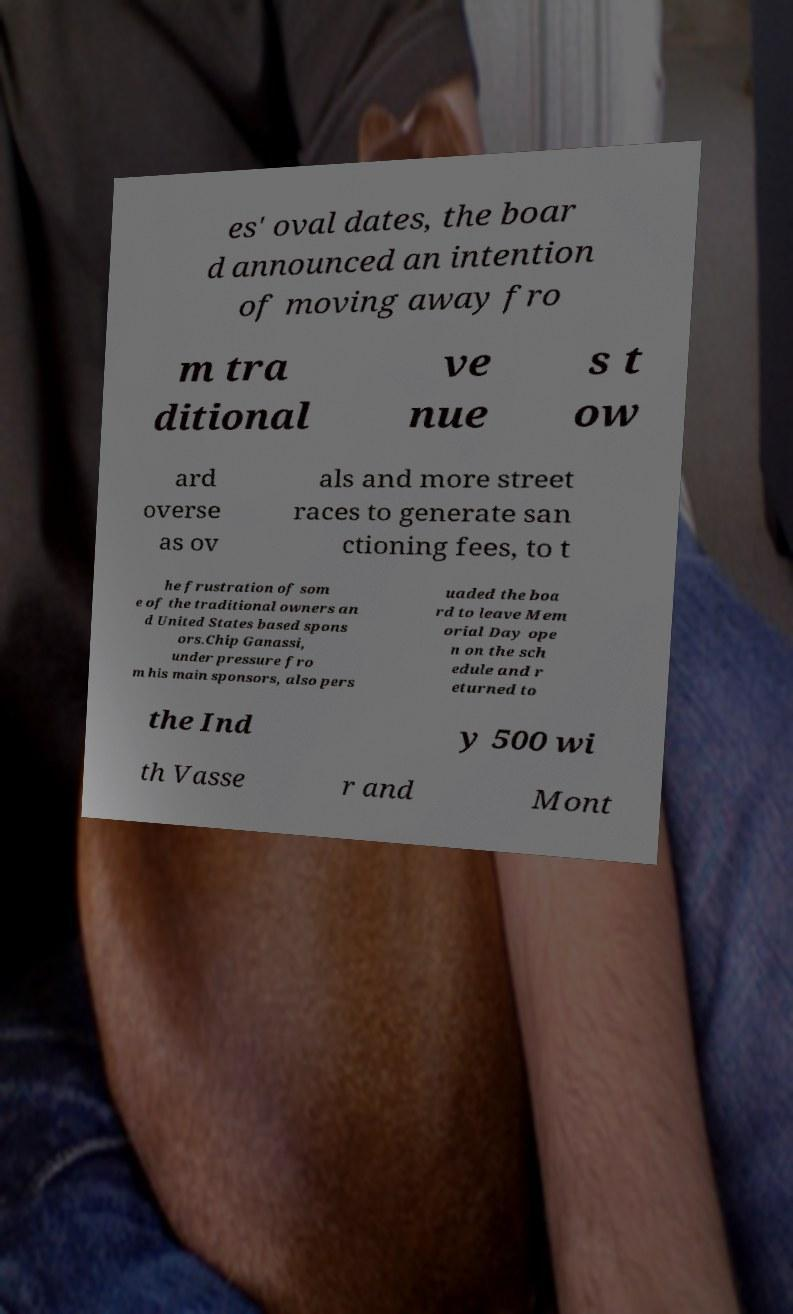Can you read and provide the text displayed in the image?This photo seems to have some interesting text. Can you extract and type it out for me? es' oval dates, the boar d announced an intention of moving away fro m tra ditional ve nue s t ow ard overse as ov als and more street races to generate san ctioning fees, to t he frustration of som e of the traditional owners an d United States based spons ors.Chip Ganassi, under pressure fro m his main sponsors, also pers uaded the boa rd to leave Mem orial Day ope n on the sch edule and r eturned to the Ind y 500 wi th Vasse r and Mont 